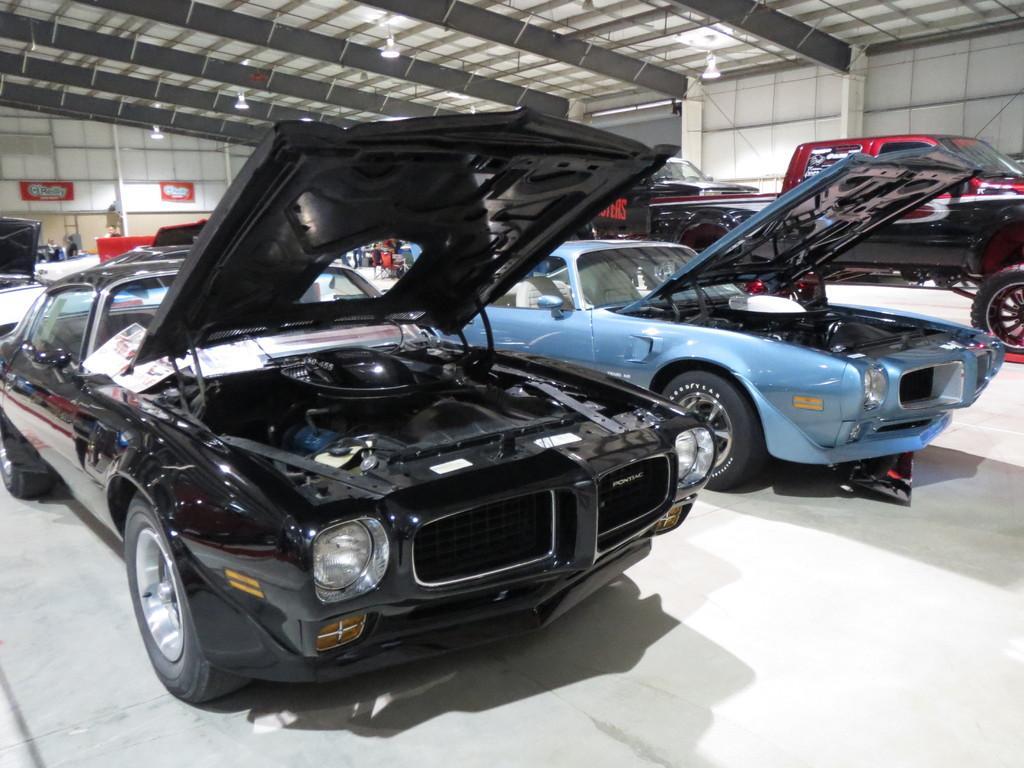In one or two sentences, can you explain what this image depicts? There are cars on the floor. Here we can see boards, lights, and roof. In the background we can see wall. 